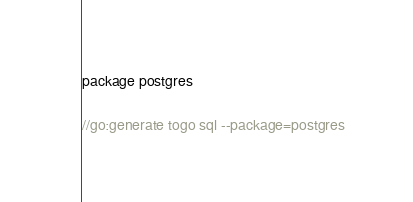Convert code to text. <code><loc_0><loc_0><loc_500><loc_500><_Go_>package postgres

//go:generate togo sql --package=postgres
</code> 